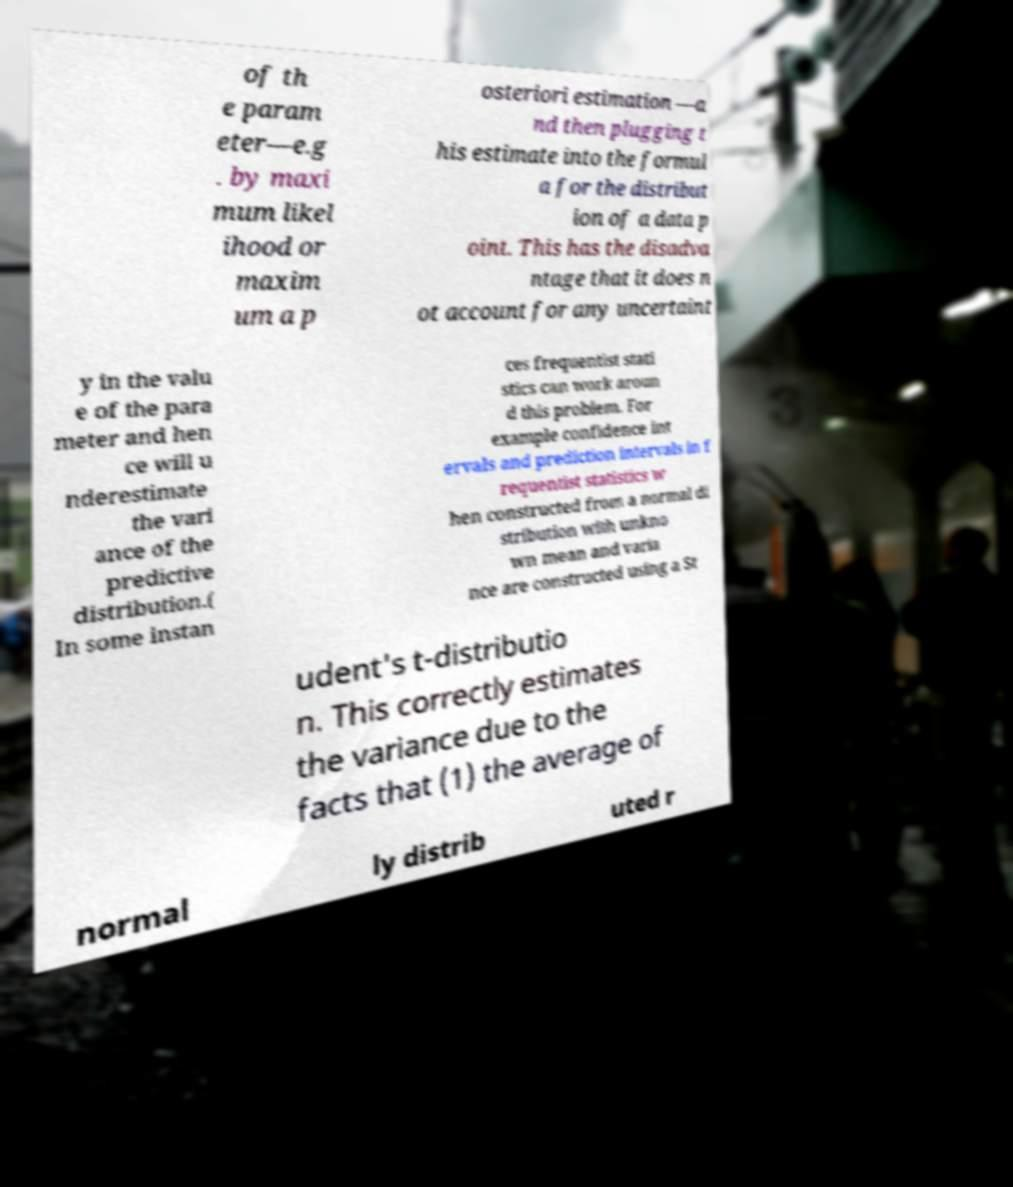Can you read and provide the text displayed in the image?This photo seems to have some interesting text. Can you extract and type it out for me? of th e param eter—e.g . by maxi mum likel ihood or maxim um a p osteriori estimation —a nd then plugging t his estimate into the formul a for the distribut ion of a data p oint. This has the disadva ntage that it does n ot account for any uncertaint y in the valu e of the para meter and hen ce will u nderestimate the vari ance of the predictive distribution.( In some instan ces frequentist stati stics can work aroun d this problem. For example confidence int ervals and prediction intervals in f requentist statistics w hen constructed from a normal di stribution with unkno wn mean and varia nce are constructed using a St udent's t-distributio n. This correctly estimates the variance due to the facts that (1) the average of normal ly distrib uted r 